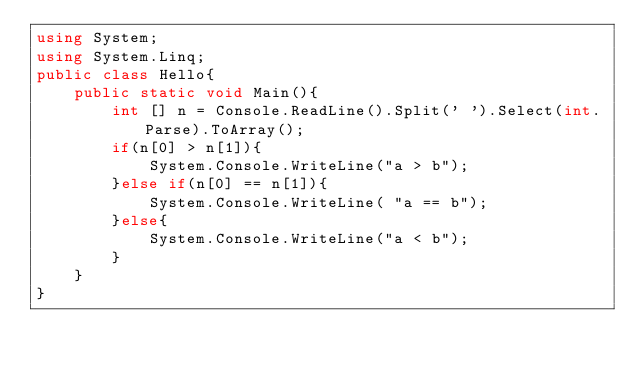Convert code to text. <code><loc_0><loc_0><loc_500><loc_500><_C#_>using System;
using System.Linq;
public class Hello{
    public static void Main(){
        int [] n = Console.ReadLine().Split(' ').Select(int.Parse).ToArray();
        if(n[0] > n[1]){
            System.Console.WriteLine("a > b");
        }else if(n[0] == n[1]){
            System.Console.WriteLine( "a == b");
        }else{
            System.Console.WriteLine("a < b");
        }
    }
}

</code> 